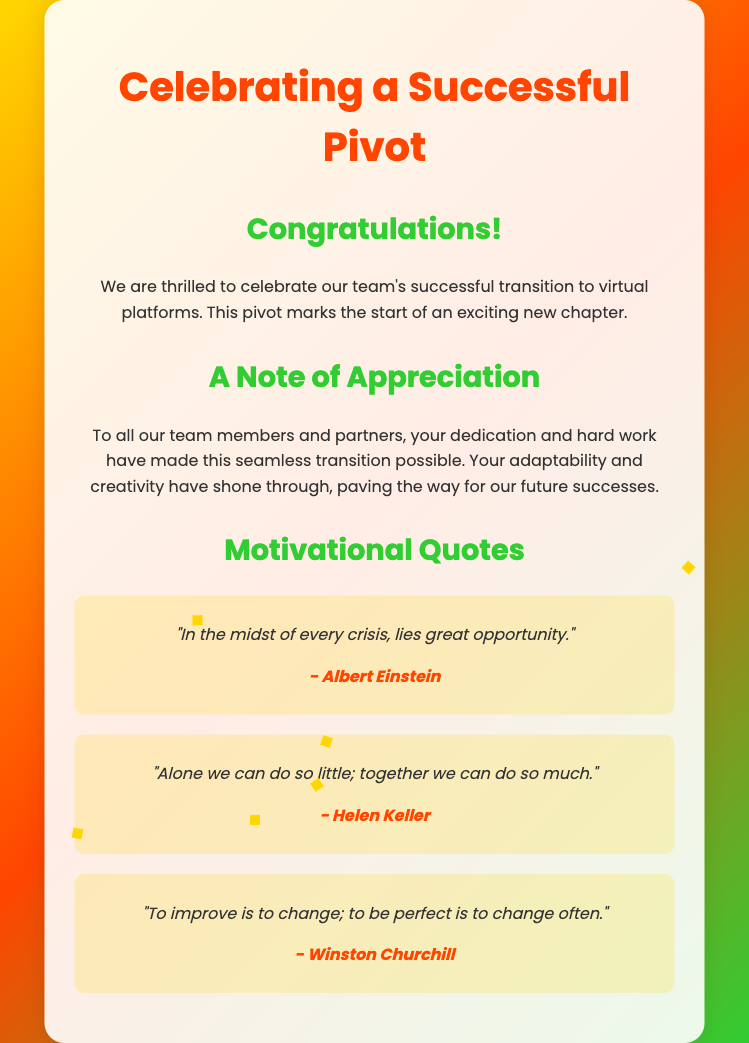What is the title of the card? The title of the card is prominently displayed at the top of the card.
Answer: Celebrating a Successful Pivot What color is used for the main heading? The main heading features a specific color that represents vibrancy and celebration.
Answer: #FF4500 How many motivational quotes are included in the card? The card lists a specific number of quotes that offer inspiration to the readers.
Answer: 3 Who is the author of the quote about opportunity? The card attributes this particular quote to a famous individual known for his contributions to science.
Answer: Albert Einstein What is mentioned as the reason for celebration in the card? The card explicitly states a significant achievement or change that prompted the celebration.
Answer: Successful transition to virtual platforms What is the background gradient color scheme of the card? The card's design features a specific combination of colors that create an uplifting atmosphere.
Answer: #FFD700, #FF4500, #32CD32 What is the font used in the card? The card utilizes a specific font family that enhances the overall design and readability.
Answer: Poppins What is the purpose of the confetti in the card? The confetti animation enhances the visual appeal and celebratory nature of the greeting card.
Answer: Celebration 